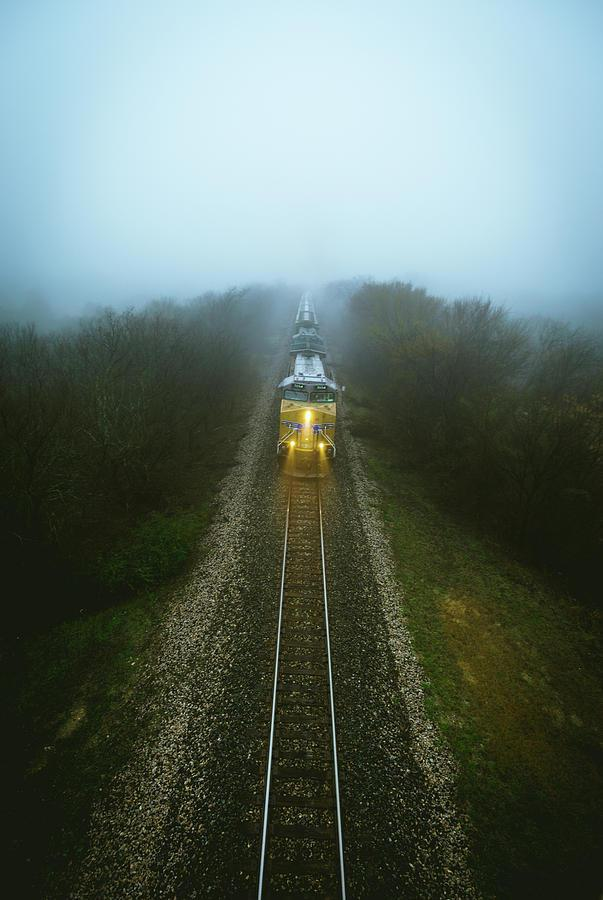Could you infer the train's direction from the image? Given the orientation of the train in the image and the position of the camera, it appears that the train is moving towards the camera, descending into the fog-covered area. 